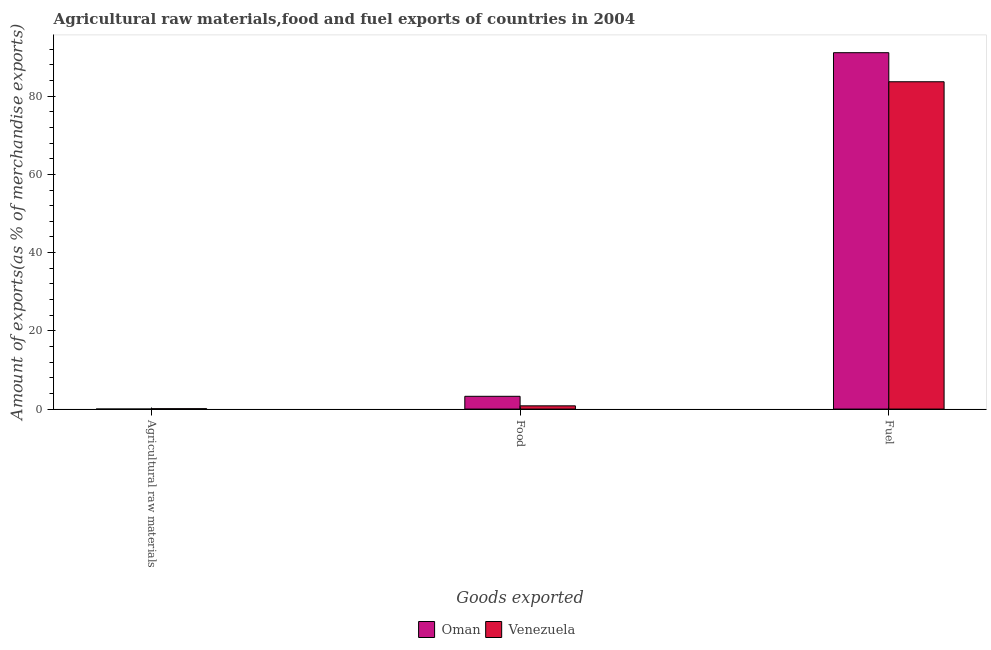How many groups of bars are there?
Offer a terse response. 3. Are the number of bars per tick equal to the number of legend labels?
Keep it short and to the point. Yes. Are the number of bars on each tick of the X-axis equal?
Make the answer very short. Yes. How many bars are there on the 2nd tick from the right?
Provide a short and direct response. 2. What is the label of the 3rd group of bars from the left?
Keep it short and to the point. Fuel. What is the percentage of food exports in Oman?
Give a very brief answer. 3.27. Across all countries, what is the maximum percentage of food exports?
Your answer should be compact. 3.27. Across all countries, what is the minimum percentage of food exports?
Give a very brief answer. 0.83. In which country was the percentage of raw materials exports maximum?
Offer a very short reply. Venezuela. In which country was the percentage of fuel exports minimum?
Provide a succinct answer. Venezuela. What is the total percentage of raw materials exports in the graph?
Give a very brief answer. 0.1. What is the difference between the percentage of food exports in Venezuela and that in Oman?
Ensure brevity in your answer.  -2.44. What is the difference between the percentage of raw materials exports in Oman and the percentage of food exports in Venezuela?
Provide a succinct answer. -0.83. What is the average percentage of raw materials exports per country?
Make the answer very short. 0.05. What is the difference between the percentage of fuel exports and percentage of raw materials exports in Venezuela?
Make the answer very short. 83.58. In how many countries, is the percentage of raw materials exports greater than 68 %?
Ensure brevity in your answer.  0. What is the ratio of the percentage of raw materials exports in Venezuela to that in Oman?
Provide a succinct answer. 29.86. Is the difference between the percentage of food exports in Oman and Venezuela greater than the difference between the percentage of fuel exports in Oman and Venezuela?
Your response must be concise. No. What is the difference between the highest and the second highest percentage of fuel exports?
Your response must be concise. 7.43. What is the difference between the highest and the lowest percentage of raw materials exports?
Keep it short and to the point. 0.09. In how many countries, is the percentage of raw materials exports greater than the average percentage of raw materials exports taken over all countries?
Provide a short and direct response. 1. What does the 1st bar from the left in Fuel represents?
Ensure brevity in your answer.  Oman. What does the 1st bar from the right in Food represents?
Provide a short and direct response. Venezuela. Are all the bars in the graph horizontal?
Provide a succinct answer. No. What is the difference between two consecutive major ticks on the Y-axis?
Provide a succinct answer. 20. Are the values on the major ticks of Y-axis written in scientific E-notation?
Your answer should be very brief. No. What is the title of the graph?
Make the answer very short. Agricultural raw materials,food and fuel exports of countries in 2004. Does "Cuba" appear as one of the legend labels in the graph?
Keep it short and to the point. No. What is the label or title of the X-axis?
Provide a short and direct response. Goods exported. What is the label or title of the Y-axis?
Make the answer very short. Amount of exports(as % of merchandise exports). What is the Amount of exports(as % of merchandise exports) in Oman in Agricultural raw materials?
Keep it short and to the point. 0. What is the Amount of exports(as % of merchandise exports) of Venezuela in Agricultural raw materials?
Ensure brevity in your answer.  0.1. What is the Amount of exports(as % of merchandise exports) in Oman in Food?
Provide a short and direct response. 3.27. What is the Amount of exports(as % of merchandise exports) of Venezuela in Food?
Ensure brevity in your answer.  0.83. What is the Amount of exports(as % of merchandise exports) of Oman in Fuel?
Ensure brevity in your answer.  91.11. What is the Amount of exports(as % of merchandise exports) of Venezuela in Fuel?
Offer a terse response. 83.68. Across all Goods exported, what is the maximum Amount of exports(as % of merchandise exports) in Oman?
Your response must be concise. 91.11. Across all Goods exported, what is the maximum Amount of exports(as % of merchandise exports) in Venezuela?
Offer a terse response. 83.68. Across all Goods exported, what is the minimum Amount of exports(as % of merchandise exports) in Oman?
Your answer should be compact. 0. Across all Goods exported, what is the minimum Amount of exports(as % of merchandise exports) in Venezuela?
Keep it short and to the point. 0.1. What is the total Amount of exports(as % of merchandise exports) in Oman in the graph?
Offer a terse response. 94.38. What is the total Amount of exports(as % of merchandise exports) in Venezuela in the graph?
Ensure brevity in your answer.  84.6. What is the difference between the Amount of exports(as % of merchandise exports) in Oman in Agricultural raw materials and that in Food?
Provide a succinct answer. -3.26. What is the difference between the Amount of exports(as % of merchandise exports) in Venezuela in Agricultural raw materials and that in Food?
Your answer should be very brief. -0.73. What is the difference between the Amount of exports(as % of merchandise exports) of Oman in Agricultural raw materials and that in Fuel?
Your response must be concise. -91.1. What is the difference between the Amount of exports(as % of merchandise exports) of Venezuela in Agricultural raw materials and that in Fuel?
Make the answer very short. -83.58. What is the difference between the Amount of exports(as % of merchandise exports) in Oman in Food and that in Fuel?
Offer a very short reply. -87.84. What is the difference between the Amount of exports(as % of merchandise exports) of Venezuela in Food and that in Fuel?
Your response must be concise. -82.85. What is the difference between the Amount of exports(as % of merchandise exports) of Oman in Agricultural raw materials and the Amount of exports(as % of merchandise exports) of Venezuela in Food?
Your answer should be compact. -0.83. What is the difference between the Amount of exports(as % of merchandise exports) of Oman in Agricultural raw materials and the Amount of exports(as % of merchandise exports) of Venezuela in Fuel?
Keep it short and to the point. -83.68. What is the difference between the Amount of exports(as % of merchandise exports) in Oman in Food and the Amount of exports(as % of merchandise exports) in Venezuela in Fuel?
Keep it short and to the point. -80.41. What is the average Amount of exports(as % of merchandise exports) of Oman per Goods exported?
Provide a short and direct response. 31.46. What is the average Amount of exports(as % of merchandise exports) in Venezuela per Goods exported?
Keep it short and to the point. 28.2. What is the difference between the Amount of exports(as % of merchandise exports) in Oman and Amount of exports(as % of merchandise exports) in Venezuela in Agricultural raw materials?
Give a very brief answer. -0.09. What is the difference between the Amount of exports(as % of merchandise exports) of Oman and Amount of exports(as % of merchandise exports) of Venezuela in Food?
Offer a terse response. 2.44. What is the difference between the Amount of exports(as % of merchandise exports) of Oman and Amount of exports(as % of merchandise exports) of Venezuela in Fuel?
Make the answer very short. 7.43. What is the ratio of the Amount of exports(as % of merchandise exports) of Venezuela in Agricultural raw materials to that in Food?
Offer a very short reply. 0.12. What is the ratio of the Amount of exports(as % of merchandise exports) of Oman in Agricultural raw materials to that in Fuel?
Keep it short and to the point. 0. What is the ratio of the Amount of exports(as % of merchandise exports) in Venezuela in Agricultural raw materials to that in Fuel?
Provide a succinct answer. 0. What is the ratio of the Amount of exports(as % of merchandise exports) in Oman in Food to that in Fuel?
Make the answer very short. 0.04. What is the ratio of the Amount of exports(as % of merchandise exports) in Venezuela in Food to that in Fuel?
Make the answer very short. 0.01. What is the difference between the highest and the second highest Amount of exports(as % of merchandise exports) of Oman?
Offer a terse response. 87.84. What is the difference between the highest and the second highest Amount of exports(as % of merchandise exports) in Venezuela?
Offer a very short reply. 82.85. What is the difference between the highest and the lowest Amount of exports(as % of merchandise exports) of Oman?
Your response must be concise. 91.1. What is the difference between the highest and the lowest Amount of exports(as % of merchandise exports) of Venezuela?
Give a very brief answer. 83.58. 